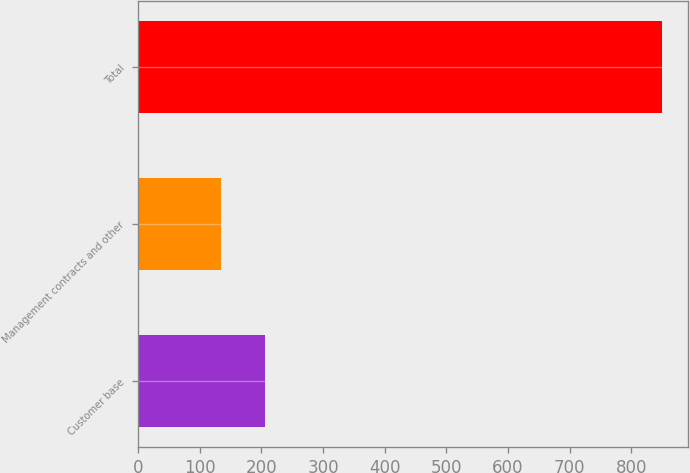Convert chart to OTSL. <chart><loc_0><loc_0><loc_500><loc_500><bar_chart><fcel>Customer base<fcel>Management contracts and other<fcel>Total<nl><fcel>205.68<fcel>134.2<fcel>849<nl></chart> 